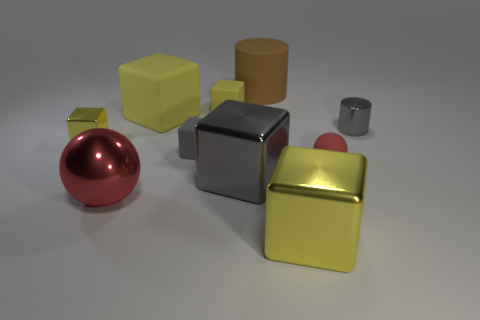Can you describe the colors and shapes of objects in the image? Certainly! The image features a variety of geometric objects in different colors and finishes. There's a glossy red sphere, a matte gold cube, a matte light yellow cube, a reflective silver cube, a glossy brown cylinder, and a metallic gray smaller cylinder. The background surface is neutral, providing contrast to the objects. 